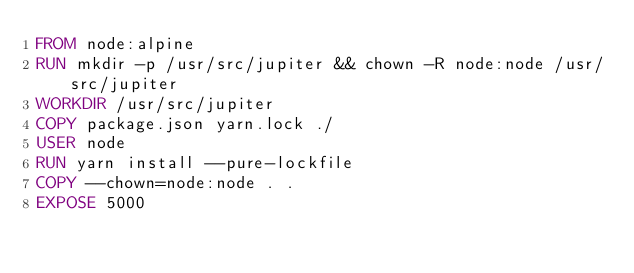Convert code to text. <code><loc_0><loc_0><loc_500><loc_500><_Dockerfile_>FROM node:alpine
RUN mkdir -p /usr/src/jupiter && chown -R node:node /usr/src/jupiter
WORKDIR /usr/src/jupiter
COPY package.json yarn.lock ./
USER node
RUN yarn install --pure-lockfile
COPY --chown=node:node . .
EXPOSE 5000
</code> 